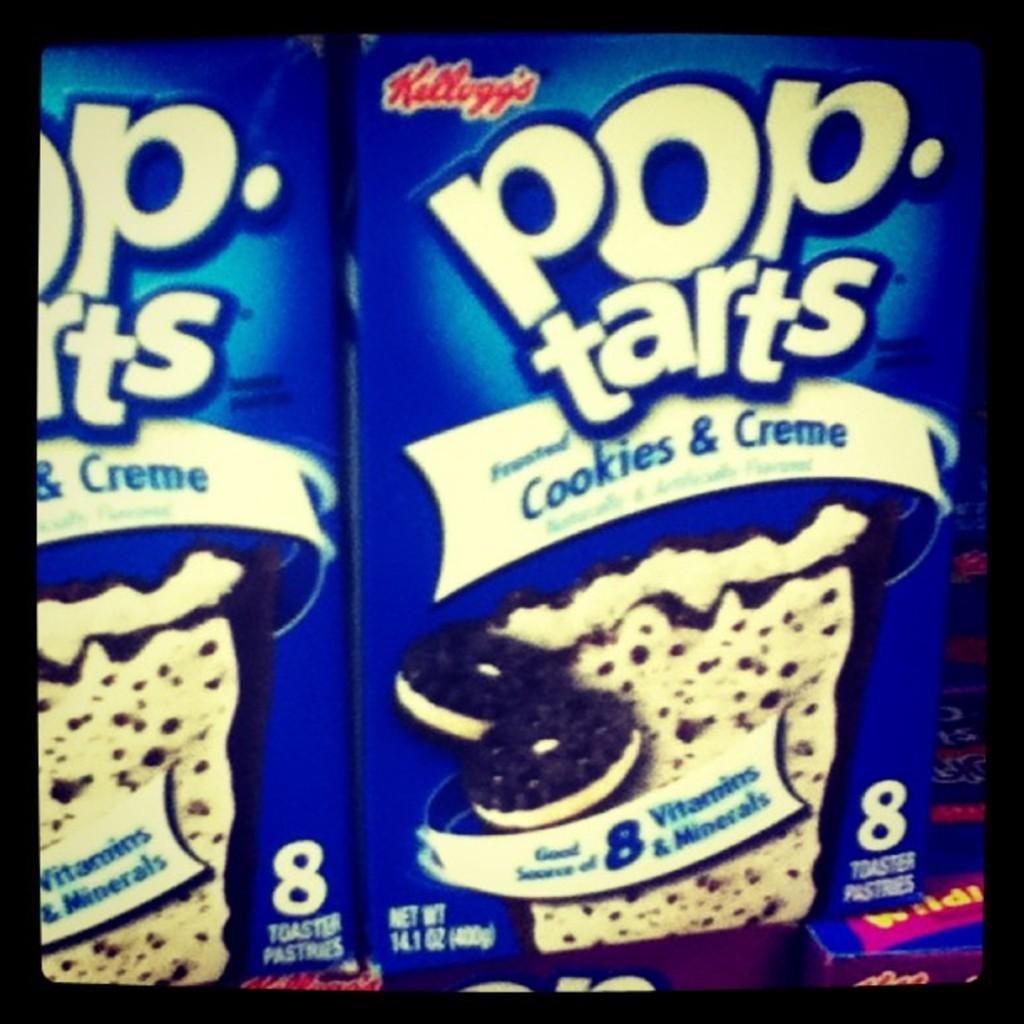Could you give a brief overview of what you see in this image? In this image there is a poster having some food and some text on it. In the picture there is some food image. Top of it there is some text on the poster. Background is in blue color. 